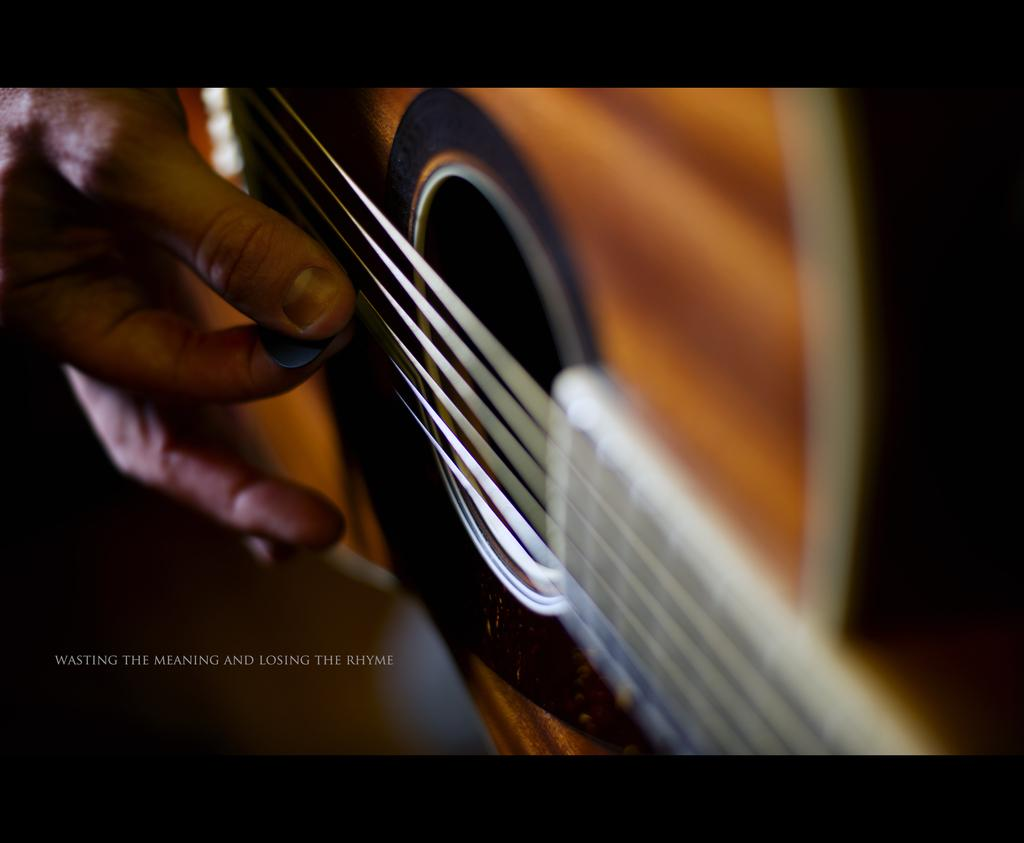What part of a person can be seen in the image? A person's hand is visible in the image. What is the person doing with their hand? The person is playing a guitar. Is there any text present in the image? Yes, there is some text in the left bottom corner of the image. Can you see a lake in the background of the image? There is no lake visible in the image. What route is the person taking while playing the guitar? The image does not show the person taking any route, as it only shows their hand playing the guitar. 